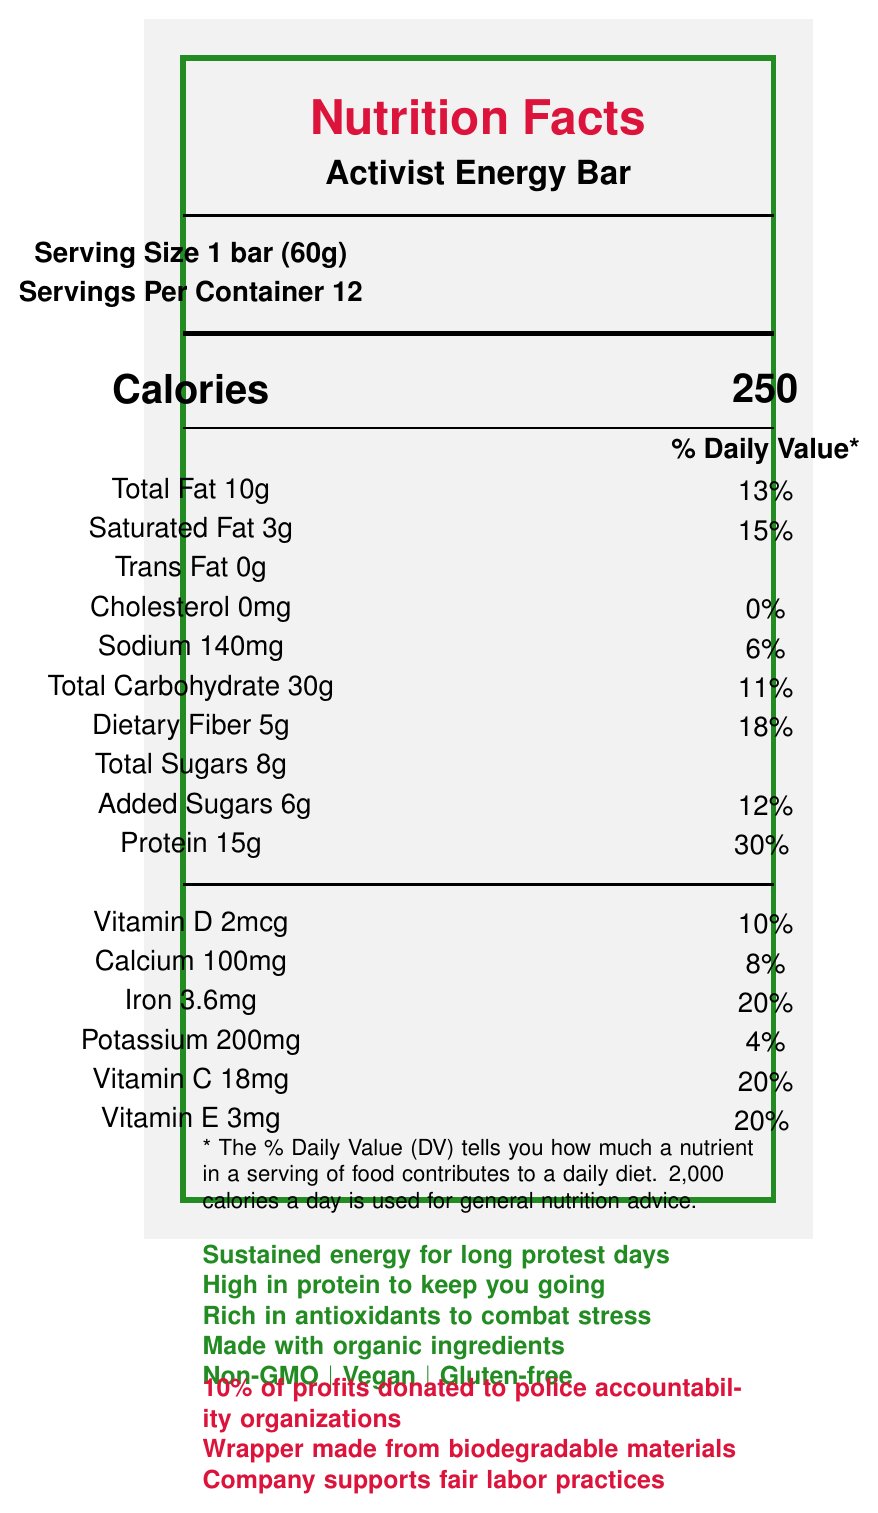what is the serving size of the Activist Energy Bar? The serving size information is explicitly stated as `Serving Size 1 bar (60g)`.
Answer: 1 bar (60g) how many calories are there in one Activist Energy Bar? It is directly stated under the Calorie information: `Calories 250`.
Answer: 250 how much protein is in a serving of the Activist Energy Bar? The amount of protein per serving is listed as 15g.
Answer: 15g how much dietary fiber does each bar provide? The dietary fiber content is shown as `Dietary Fiber 5g`.
Answer: 5g what percentage of the daily value is the iron content in one bar? The daily value percentage for iron is shown as `Iron 3.6mg - 20%`.
Answer: 20% does the Activist Energy Bar contain any cholesterol? The cholesterol content is listed as `0mg`, with a daily value percentage of `0%`.
Answer: No what are three key marketing claims of the Activist Energy Bar? These claims are listed under the marketing claims section.
Answer: Sustained energy for long protest days, High in protein to keep you going, Rich in antioxidants to combat stress how much calcium is in one serving, and what percentage of the daily value does it represent? The calcium content is given as `Calcium 100mg`, which represents `8%` of the daily value.
Answer: 100mg, 8% what is the sodium content in one Activist Energy Bar? The sodium content is listed as `Sodium 140mg`.
Answer: 140mg how much added sugar does one serving contain? The added sugar content is shown as `Added Sugars 6g`.
Answer: 6g which of the following nutrients has the highest percentage of daily value in one serving?
A. Iron
B. Protein
C. Dietary Fiber
D. Vitamin E Protein has a daily value of 30%, which is the highest among the listed options.
Answer: B. Protein how much total carbohydrate is in one bar? The total carbohydrate amount is listed as `Total Carbohydrate 30g`.
Answer: 30g does the Activist Energy Bar support any specific causes? The document mentions `10% of profits donated to police accountability organizations`.
Answer: Yes how many servings are in one container of the Activist Energy Bar? It states `Servings Per Container 12`.
Answer: 12 describe the main idea of this document. The main information includes serving size, calorie content, nutrients, ingredients, marketing claims, and activism facts.
Answer: The document provides comprehensive nutritional information about the Activist Energy Bar. It details the serving size, calorie content, macronutrients, micronutrients, marketing claims, list of organic ingredients, allergen information, and the brand’s commitment to activism and social causes. is the wrapper of the Activist Energy Bar eco-friendly? The document notes that the wrapper is made from biodegradable materials.
Answer: Yes how many grams of saturated fat are in one serving? The saturated fat content is `Saturated Fat 3g`.
Answer: 3g which vitamin has the same daily value percentage in one bar: Vitamin C or Vitamin E? Both Vitamin C and Vitamin E have a daily value percentage of 20%.
Answer: Both what are the main ingredients of the Activist Energy Bar? These ingredients are listed in the document.
Answer: Organic brown rice protein, Organic dates, Organic almonds, Organic peanut butter, Organic chia seeds, Organic coconut oil, Organic cocoa powder, Organic vanilla extract, Sea salt what is the potassium content per serving? The potassium content is listed as `Potassium 200mg`.
Answer: 200mg what is the source of protein in the Activist Energy Bar? The primary protein source is `Organic brown rice protein`.
Answer: Organic brown rice protein how much Vitamin D does one serving provide? The Vitamin D content is listed as `Vitamin D 2mcg`.
Answer: 2mcg which of these is not explicitly stated about the Activist Energy Bar: A. Gluten-free B. Contains soy C. Contains almonds The allergen information mentions that it may contain traces of soy but does not explicitly state that it contains soy.
Answer: B. Contains soy what percentage of daily value does 140mg of sodium represent? The daily value percentage for sodium is listed as `6%`.
Answer: 6% what is the distinction made in the document about sugars? The document differentiates between `Total Sugars 8g` and `Added Sugars 6g`.
Answer: Total Sugars vs. Added Sugars which nutrient contributes no daily value percentage in the Activist Energy Bar? Trans fat is listed as `Trans Fat 0g` with no daily value percentage.
Answer: Trans fat how much Vitamin C is in a serving of the Activist Energy Bar? The Vitamin C content is listed as `Vitamin C 18mg`.
Answer: 18mg does the document provide the price of the Activist Energy Bar? The document does not mention the price; hence, it cannot be determined.
Answer: Not enough information 